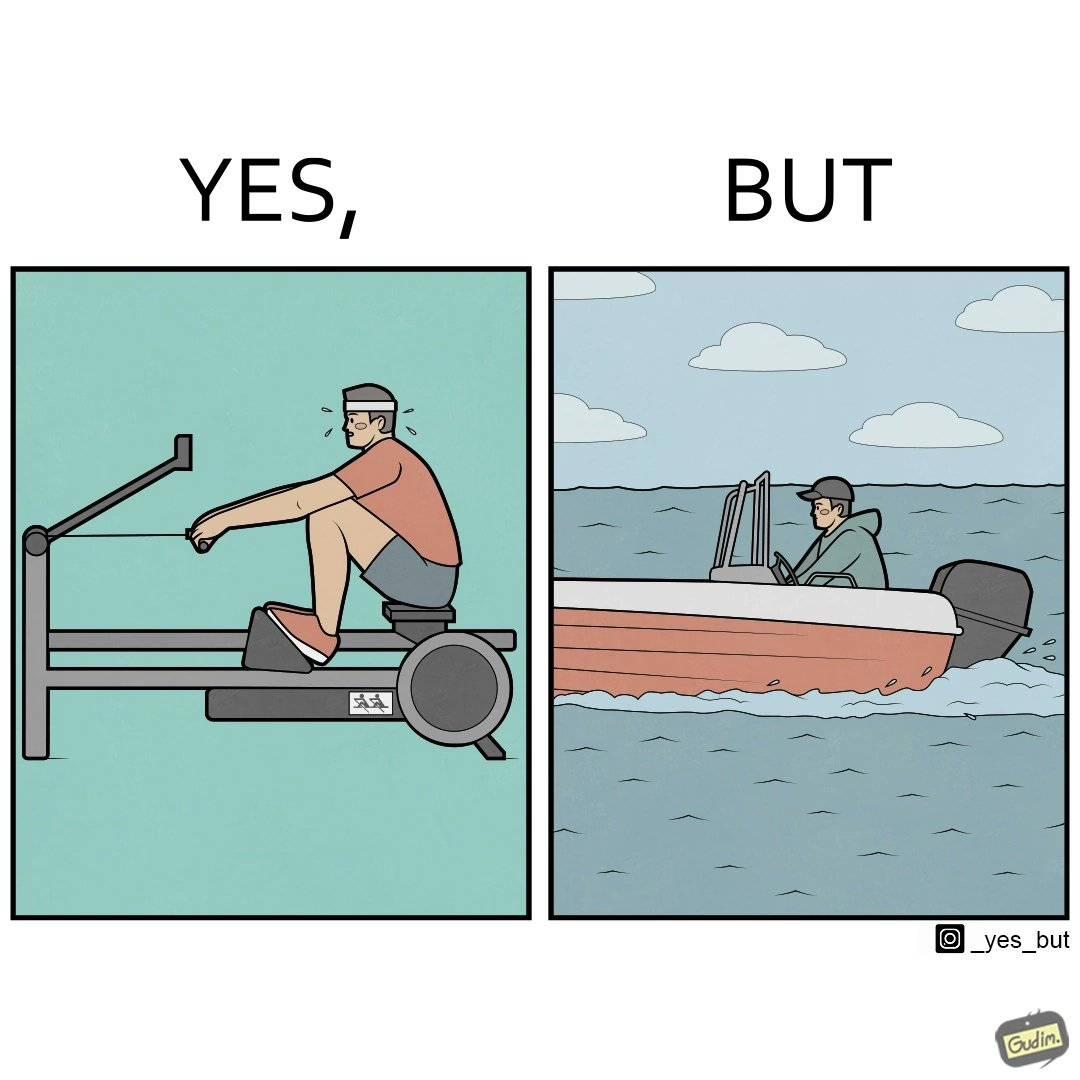Compare the left and right sides of this image. In the left part of the image: a person doing rowing exercise in gym In the right part of the image: a person riding a motorboat 